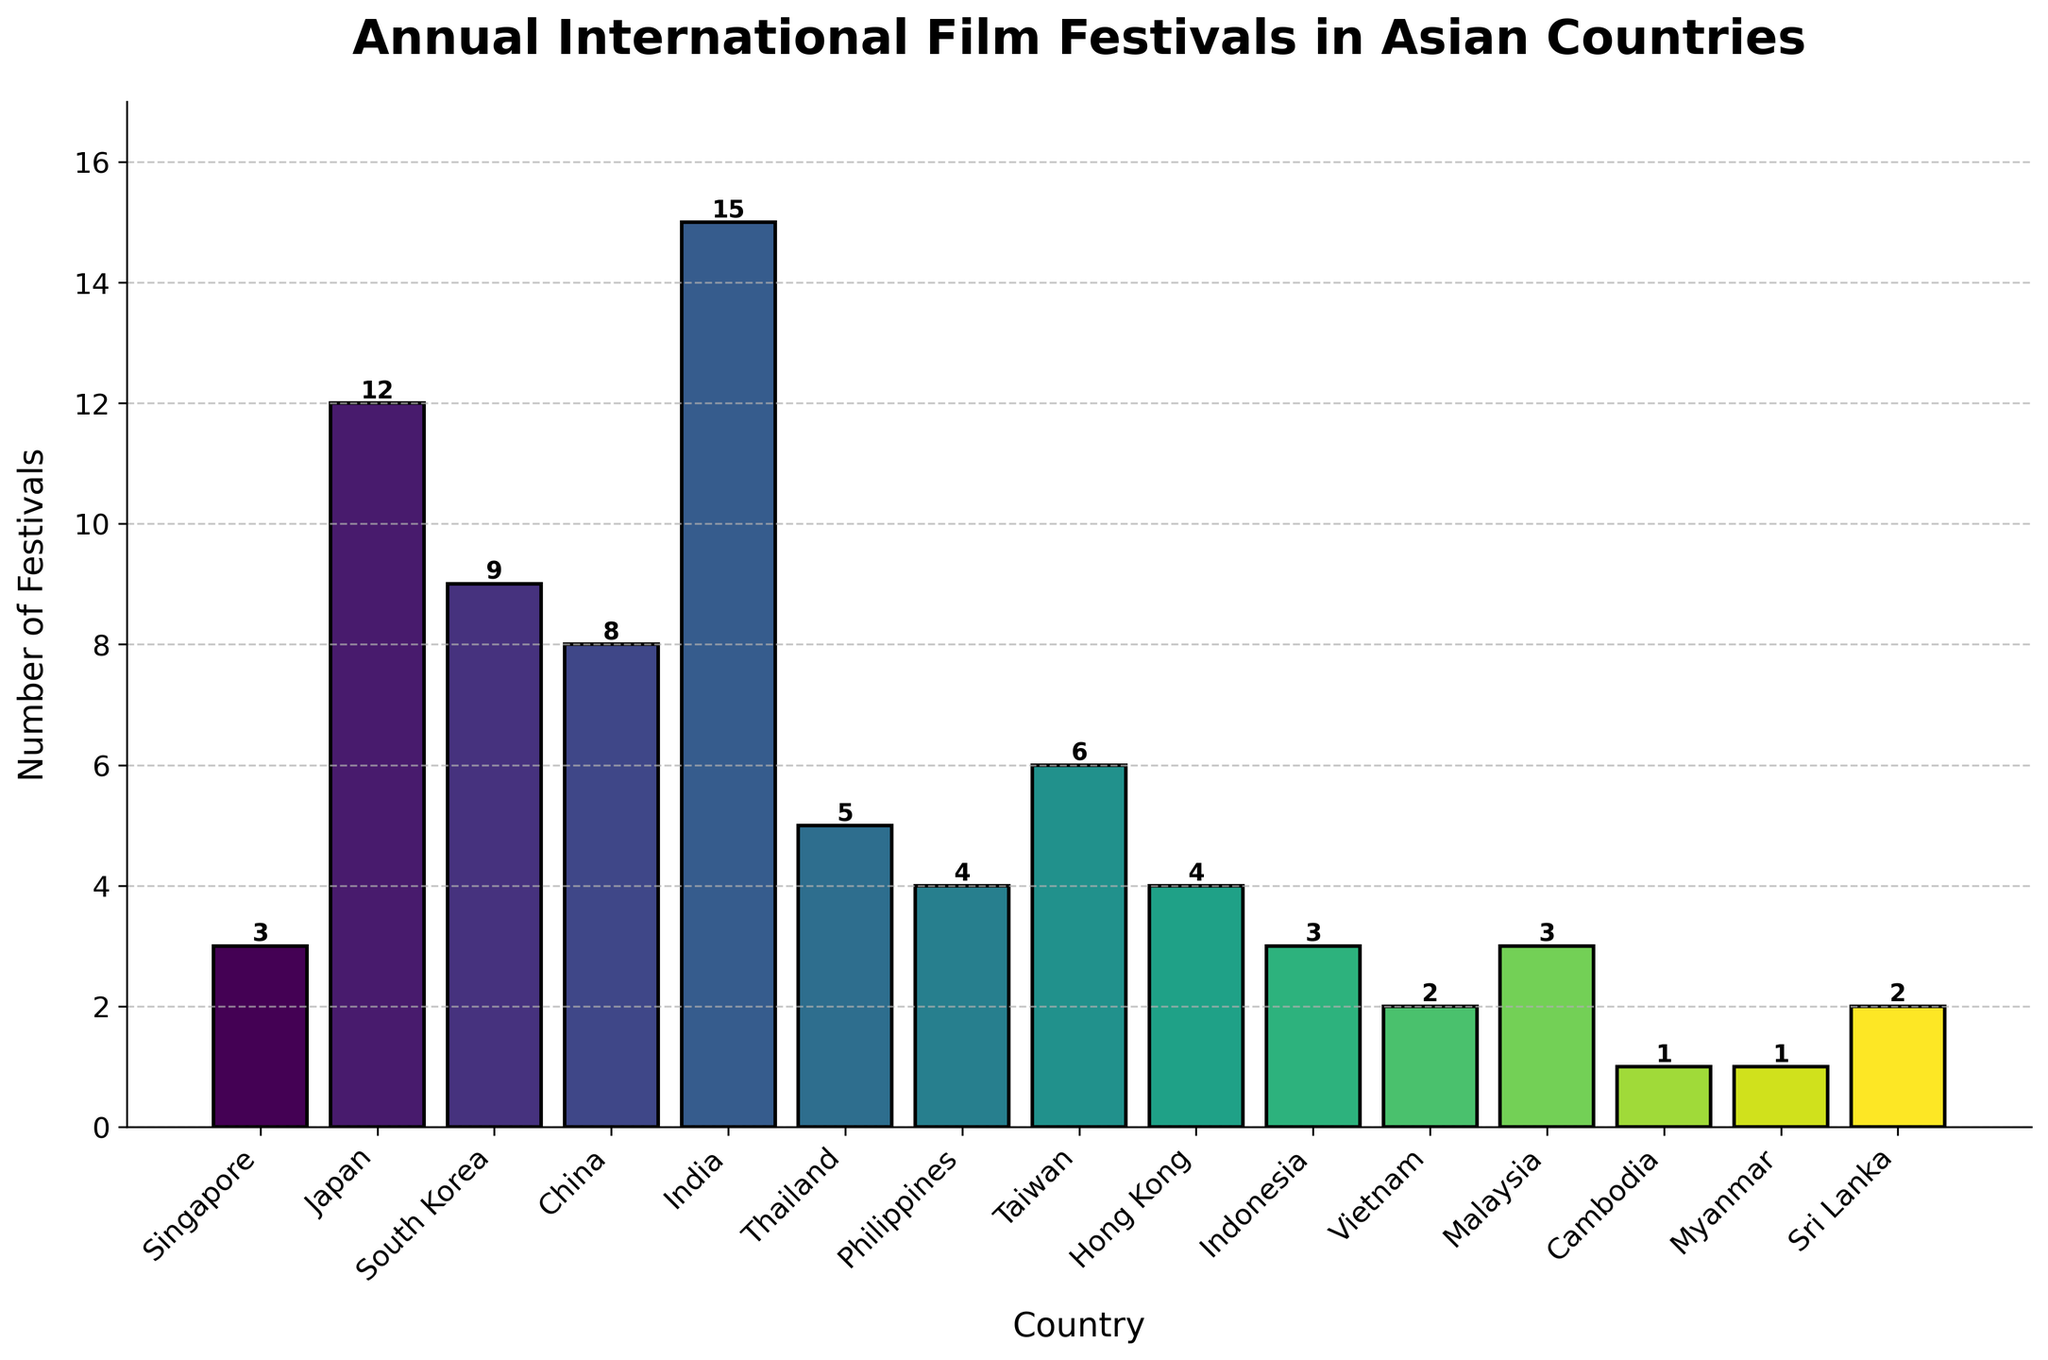What's the total number of international film festivals held in Japan and South Korea annually? To find the total number, sum the values for Japan and South Korea. Japan holds 12 festivals and South Korea holds 9 festivals. 12 + 9 = 21
Answer: 21 Which country hosts the highest number of international film festivals annually? By examining the heights of the bars, India has the tallest bar, indicating it hosts the most festivals. The label confirms that India holds 15 festivals annually.
Answer: India Which country hosts more international film festivals annually, Philippines or Taiwan? Look at the bars for Philippines and Taiwan. Philippines hosts 4 festivals, and Taiwan hosts 6. 6 (Taiwan) is greater than 4 (Philippines).
Answer: Taiwan What's the average number of international film festivals held annually in Singapore, Indonesia, and Malaysia? Add the annual numbers for Singapore (3), Indonesia (3), and Malaysia (3), then divide by 3. (3 + 3 + 3) / 3 = 9 / 3 = 3
Answer: 3 Which countries host exactly 4 international film festivals annually? Identify the bars with a height of 4. Both Philippines and Hong Kong have bars with a height of 4.
Answer: Philippines, Hong Kong How many more international film festivals are held in Thailand than in Vietnam annually? Thailand hosts 5 festivals while Vietnam hosts 2. Subtract the number in Vietnam from the number in Thailand. 5 - 2 = 3
Answer: 3 Sort the countries in descending order based on the number of international film festivals they host annually, excluding India. Excluding India (15), the remaining data in descending order are: Japan (12), South Korea (9), China (8), Taiwan (6), Thailand (5), Philippines (4), Hong Kong (4), Singapore (3), Indonesia (3), Malaysia (3), Vietnam (2), Sri Lanka (2), Cambodia (1), Myanmar (1).
Answer: Japan, South Korea, China, Taiwan, Thailand, Philippines, Hong Kong, Singapore, Indonesia, Malaysia, Vietnam, Sri Lanka, Cambodia, Myanmar Which countries host the same number of international film festivals as Singapore annually? Look at the bars for Singapore and identify bars with the same height. Singapore hosts 3 festivals. Both Indonesia and Malaysia also host 3 festivals.
Answer: Indonesia, Malaysia 